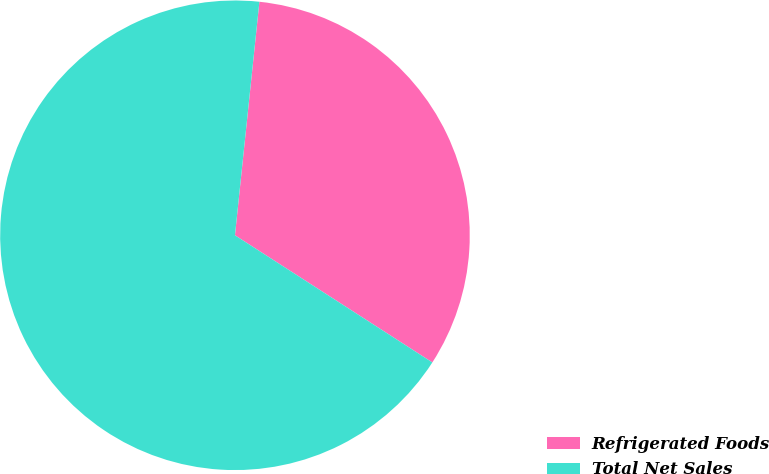Convert chart to OTSL. <chart><loc_0><loc_0><loc_500><loc_500><pie_chart><fcel>Refrigerated Foods<fcel>Total Net Sales<nl><fcel>32.45%<fcel>67.55%<nl></chart> 